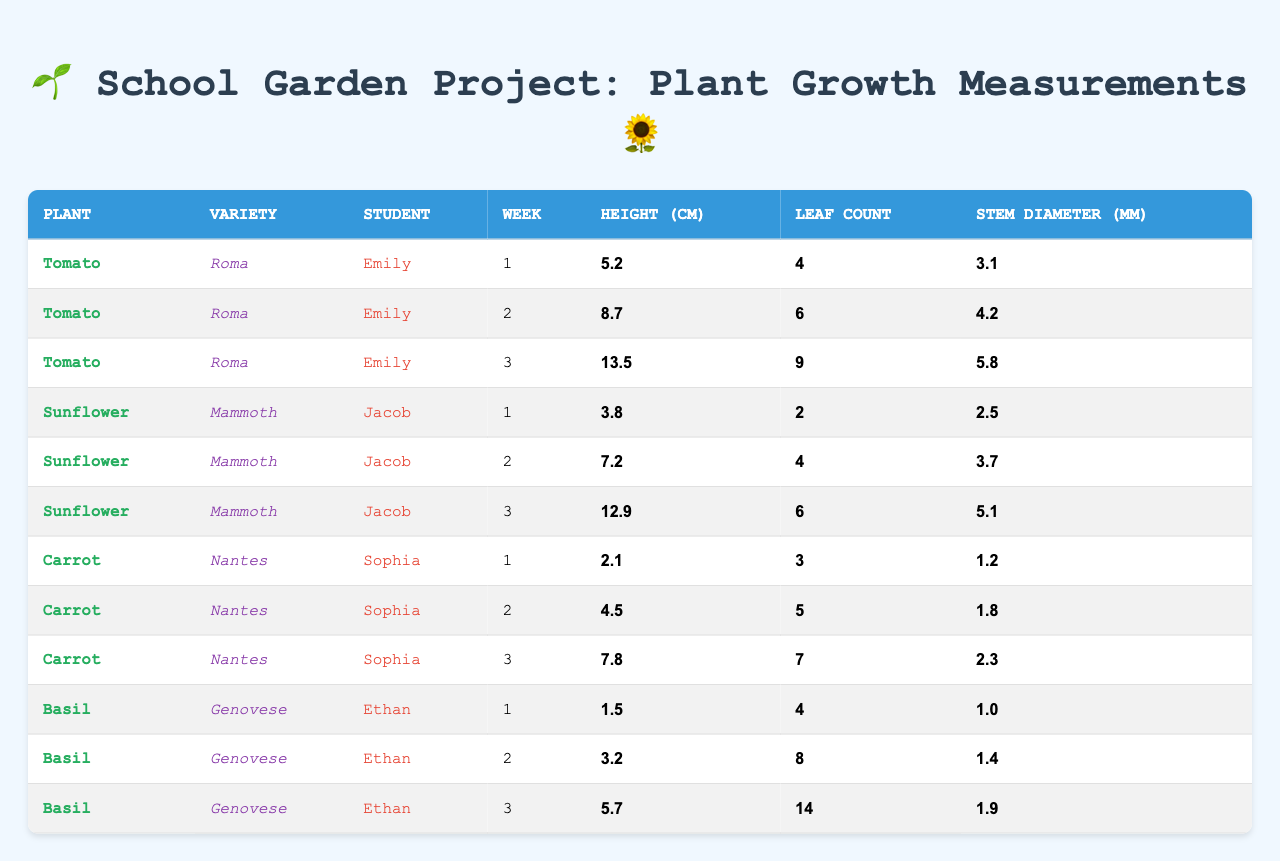What is the height of the Tomato plant in week 3? From the table, we can locate the Tomato plant records and find the height for week 3, which is 13.5 cm.
Answer: 13.5 cm How many leaves did the Sunflower plant have in week 2? Looking at the Sunflower plant records, the leaf count for week 2 is 4.
Answer: 4 Which student tends the Basil plant? The table shows that Ethan is the student who tends the Basil plant.
Answer: Ethan What is the average height of the Carrot plants over the three weeks? To find the average height, we sum the heights for the Carrot plants: 2.1 + 4.5 + 7.8 = 14.4 cm. Then we divide by 3 (the number of weeks), which gives us an average of 14.4/3 = 4.8 cm.
Answer: 4.8 cm True or False: The maximum stem diameter for the Sunflower plant was 5.1 mm. By reviewing the stem diameter values for the Sunflower plants over the three weeks, the maximum stem diameter recorded is indeed 5.1 mm. Therefore, the statement is true.
Answer: True What is the difference in height between the Basil plant in week 1 and week 3? The height of the Basil plant in week 1 is 1.5 cm, and in week 3, it is 5.7 cm. The difference is calculated as 5.7 - 1.5 = 4.2 cm.
Answer: 4.2 cm How many leaf counts did the Tomato plant increase from week 1 to week 3? The leaf count for the Tomato plant in week 1 is 4 and in week 3 is 9. The increase is 9 - 4 = 5 leaves.
Answer: 5 leaves What is the total stem diameter of all plants in week 2? Summing the stem diameters for all plants in week 2 gives us: 4.2 (Tomato) + 3.7 (Sunflower) + 1.8 (Carrot) + 1.4 (Basil) = 11.1 mm.
Answer: 11.1 mm Which plant variety had the highest average height across all weeks? Calculating the average height for each variety: Tomato: (5.2 + 8.7 + 13.5)/3 = 9.4667 cm, Sunflower: (3.8 + 7.2 + 12.9)/3 = 7.3333 cm, Carrot: (2.1 + 4.5 + 7.8)/3 = 4.8 cm, Basil: (1.5 + 3.2 + 5.7)/3 = 3.4667 cm. Therefore, the Tomato variety has the highest average height.
Answer: Tomato How many more leaves did the Carrot plant have in week 3 compared to week 1? The leaf count for the Carrot plant in week 3 is 7, and in week 1, it is 3. Thus, the difference is 7 - 3 = 4 leaves.
Answer: 4 leaves 